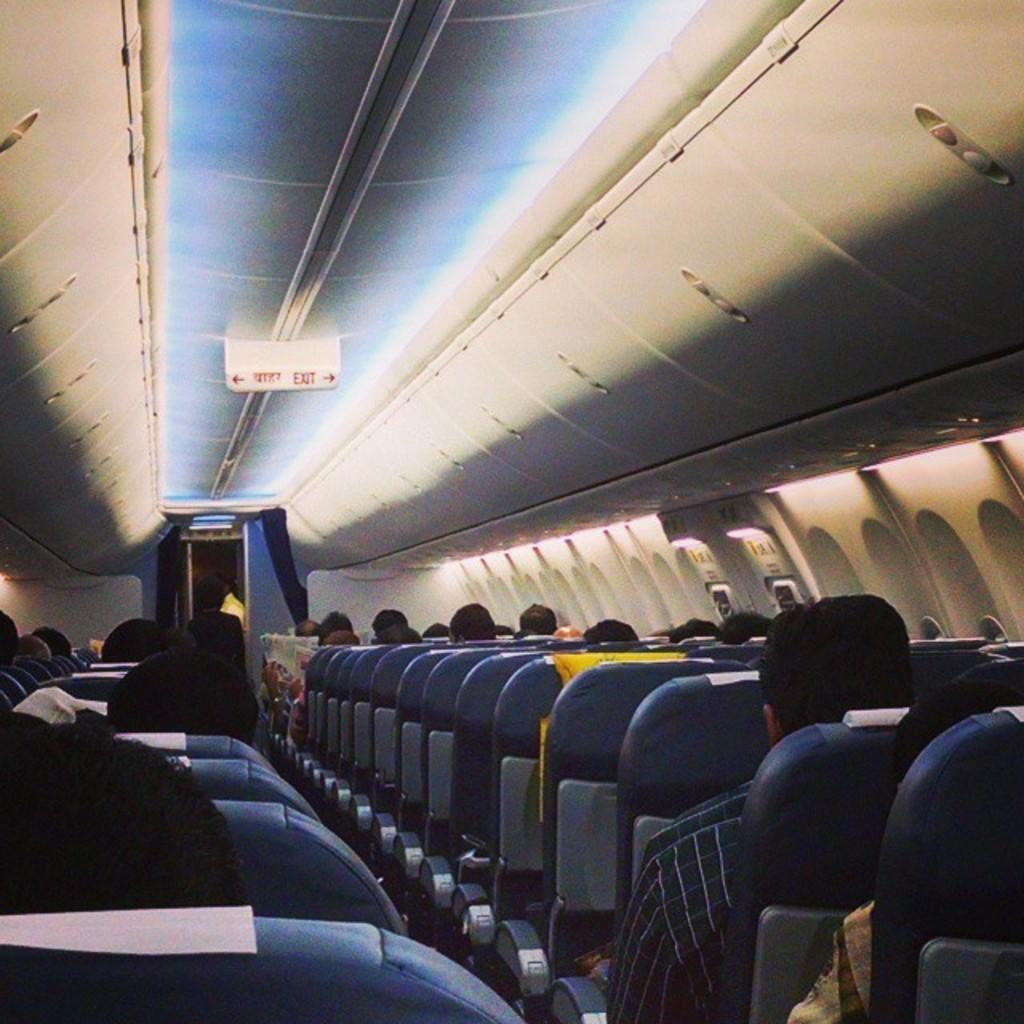Does this plane have an exit?
Your answer should be compact. Yes. 